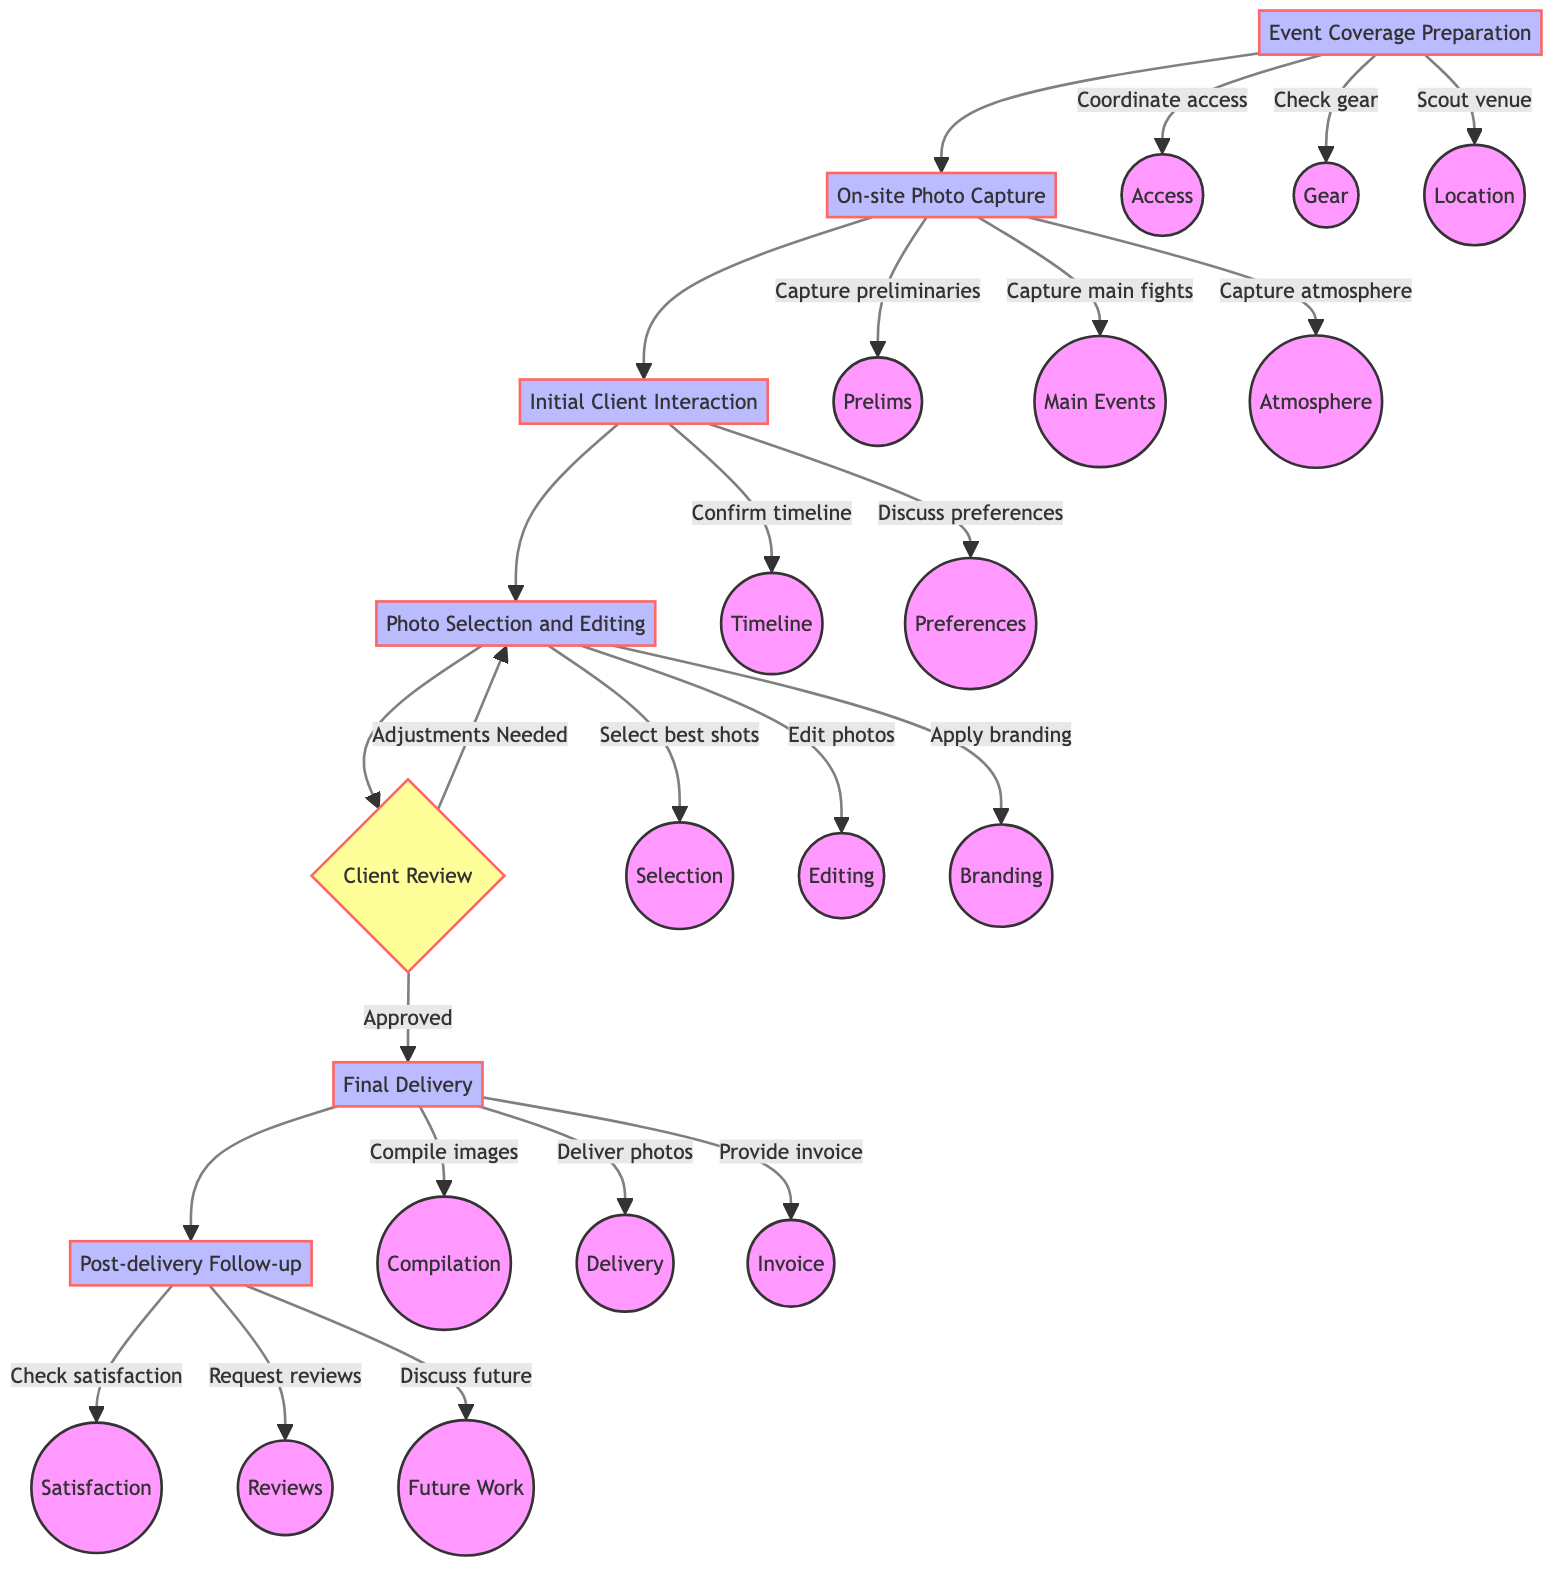What is the first step in the client interaction process? The first step is "Initial Client Interaction," which is the first process after on-site photo capture before moving on to photo selection and editing.
Answer: Initial Client Interaction How many main processes are there in the diagram? There are six main processes listed in the diagram from Event Coverage Preparation to Post-delivery Follow-up.
Answer: Six What follows after the Photo Selection and Editing step? After Photo Selection and Editing, the next step is Client Review, where the previews are sent to the client for feedback.
Answer: Client Review What happens during the client review if adjustments are needed? If adjustments are needed, the process loops back to Photo Selection and Editing for further refinements before resubmitting to the client.
Answer: Loop back to Photo Selection and Editing What are the three activities listed under the Final Delivery process? The three activities are compiling images, delivering photos, and providing an invoice for services.
Answer: Compile images, deliver photos, provide invoice In which step is the timeline confirmed with the client? The timeline is confirmed during the "Initial Client Interaction" step, where the photographer discusses photo delivery timelines with the client.
Answer: Initial Client Interaction How does the process end after Final Delivery? After Final Delivery, the process ends with Post-delivery Follow-up, ensuring the client's satisfaction and discussing future collaborations.
Answer: Post-delivery Follow-up How many activities are involved in Photo Selection and Editing? There are three activities involved in Photo Selection and Editing: selecting the best shots, editing photos, and applying branding.
Answer: Three activities What can a client request during the Initial Client Interaction? A client can request a specific timeline and preferences for photo edits during the Initial Client Interaction process.
Answer: Specific timeline and preferences for photo edits 